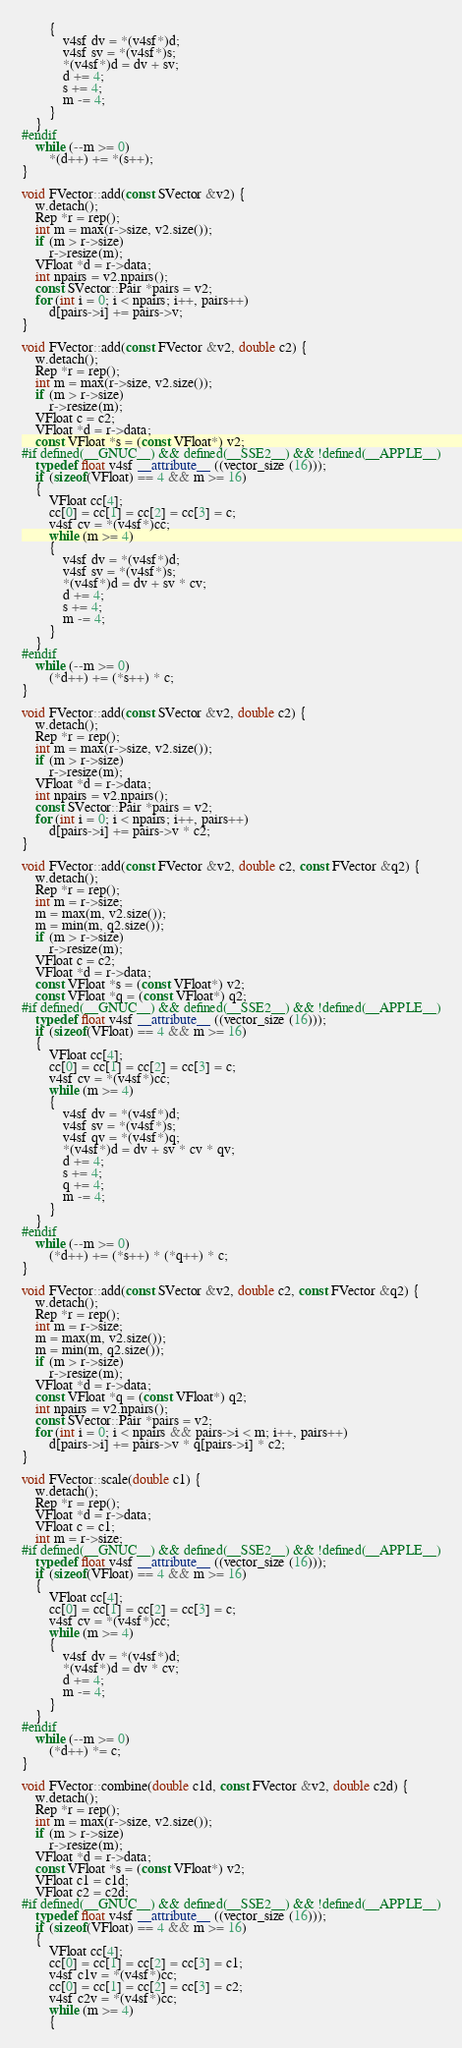Convert code to text. <code><loc_0><loc_0><loc_500><loc_500><_C++_>		{
			v4sf dv = *(v4sf*)d;
			v4sf sv = *(v4sf*)s;
			*(v4sf*)d = dv + sv;
			d += 4;
			s += 4;
			m -= 4;
		}
	}
#endif
	while (--m >= 0)
		*(d++) += *(s++);
}

void FVector::add(const SVector &v2) {
	w.detach();
	Rep *r = rep();
	int m = max(r->size, v2.size());
	if (m > r->size)
		r->resize(m);
	VFloat *d = r->data;
	int npairs = v2.npairs();
	const SVector::Pair *pairs = v2;
	for (int i = 0; i < npairs; i++, pairs++)
		d[pairs->i] += pairs->v;
}

void FVector::add(const FVector &v2, double c2) {
	w.detach();
	Rep *r = rep();
	int m = max(r->size, v2.size());
	if (m > r->size)
		r->resize(m);
	VFloat c = c2;
	VFloat *d = r->data;
	const VFloat *s = (const VFloat*) v2;
#if defined(__GNUC__) && defined(__SSE2__) && !defined(__APPLE__)
	typedef float v4sf __attribute__ ((vector_size (16)));
	if (sizeof(VFloat) == 4 && m >= 16)
	{
		VFloat cc[4];
		cc[0] = cc[1] = cc[2] = cc[3] = c;
		v4sf cv = *(v4sf*)cc;
		while (m >= 4)
		{
			v4sf dv = *(v4sf*)d;
			v4sf sv = *(v4sf*)s;
			*(v4sf*)d = dv + sv * cv;
			d += 4;
			s += 4;
			m -= 4;
		}
	}
#endif
	while (--m >= 0)
		(*d++) += (*s++) * c;
}

void FVector::add(const SVector &v2, double c2) {
	w.detach();
	Rep *r = rep();
	int m = max(r->size, v2.size());
	if (m > r->size)
		r->resize(m);
	VFloat *d = r->data;
	int npairs = v2.npairs();
	const SVector::Pair *pairs = v2;
	for (int i = 0; i < npairs; i++, pairs++)
		d[pairs->i] += pairs->v * c2;
}

void FVector::add(const FVector &v2, double c2, const FVector &q2) {
	w.detach();
	Rep *r = rep();
	int m = r->size;
	m = max(m, v2.size());
	m = min(m, q2.size());
	if (m > r->size)
		r->resize(m);
	VFloat c = c2;
	VFloat *d = r->data;
	const VFloat *s = (const VFloat*) v2;
	const VFloat *q = (const VFloat*) q2;
#if defined(__GNUC__) && defined(__SSE2__) && !defined(__APPLE__)
	typedef float v4sf __attribute__ ((vector_size (16)));
	if (sizeof(VFloat) == 4 && m >= 16)
	{
		VFloat cc[4];
		cc[0] = cc[1] = cc[2] = cc[3] = c;
		v4sf cv = *(v4sf*)cc;
		while (m >= 4)
		{
			v4sf dv = *(v4sf*)d;
			v4sf sv = *(v4sf*)s;
			v4sf qv = *(v4sf*)q;
			*(v4sf*)d = dv + sv * cv * qv;
			d += 4;
			s += 4;
			q += 4;
			m -= 4;
		}
	}
#endif
	while (--m >= 0)
		(*d++) += (*s++) * (*q++) * c;
}

void FVector::add(const SVector &v2, double c2, const FVector &q2) {
	w.detach();
	Rep *r = rep();
	int m = r->size;
	m = max(m, v2.size());
	m = min(m, q2.size());
	if (m > r->size)
		r->resize(m);
	VFloat *d = r->data;
	const VFloat *q = (const VFloat*) q2;
	int npairs = v2.npairs();
	const SVector::Pair *pairs = v2;
	for (int i = 0; i < npairs && pairs->i < m; i++, pairs++)
		d[pairs->i] += pairs->v * q[pairs->i] * c2;
}

void FVector::scale(double c1) {
	w.detach();
	Rep *r = rep();
	VFloat *d = r->data;
	VFloat c = c1;
	int m = r->size;
#if defined(__GNUC__) && defined(__SSE2__) && !defined(__APPLE__)
	typedef float v4sf __attribute__ ((vector_size (16)));
	if (sizeof(VFloat) == 4 && m >= 16)
	{
		VFloat cc[4];
		cc[0] = cc[1] = cc[2] = cc[3] = c;
		v4sf cv = *(v4sf*)cc;
		while (m >= 4)
		{
			v4sf dv = *(v4sf*)d;
			*(v4sf*)d = dv * cv;
			d += 4;
			m -= 4;
		}
	}
#endif
	while (--m >= 0)
		(*d++) *= c;
}

void FVector::combine(double c1d, const FVector &v2, double c2d) {
	w.detach();
	Rep *r = rep();
	int m = max(r->size, v2.size());
	if (m > r->size)
		r->resize(m);
	VFloat *d = r->data;
	const VFloat *s = (const VFloat*) v2;
	VFloat c1 = c1d;
	VFloat c2 = c2d;
#if defined(__GNUC__) && defined(__SSE2__) && !defined(__APPLE__)
	typedef float v4sf __attribute__ ((vector_size (16)));
	if (sizeof(VFloat) == 4 && m >= 16)
	{
		VFloat cc[4];
		cc[0] = cc[1] = cc[2] = cc[3] = c1;
		v4sf c1v = *(v4sf*)cc;
		cc[0] = cc[1] = cc[2] = cc[3] = c2;
		v4sf c2v = *(v4sf*)cc;
		while (m >= 4)
		{</code> 